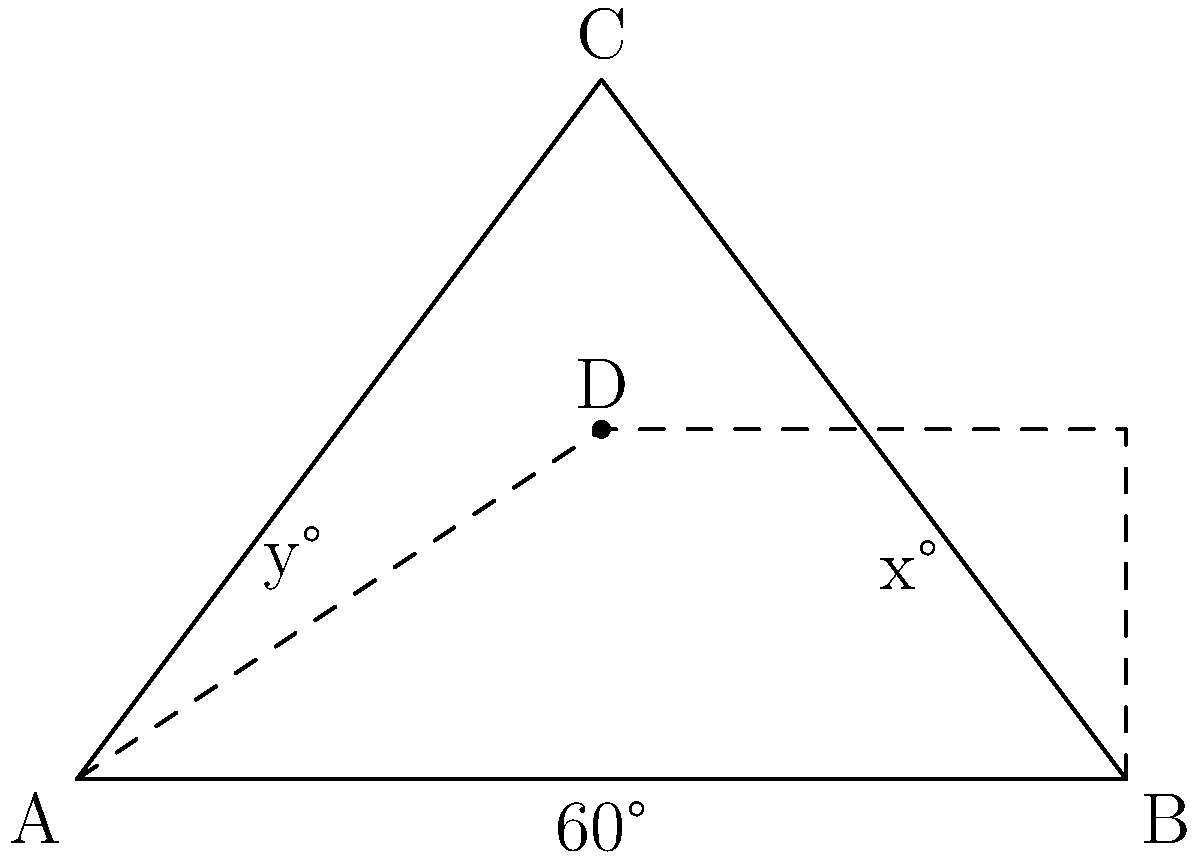For a multi-tiered display stand to showcase Rocket Raccoon props, you're designing a triangular base. The bottom tier forms an equilateral triangle ABC with a 60° angle at the base. Two shelves are placed parallel to the base, dividing the height into three equal parts. If the angle between the bottom shelf and side AC is x°, and the angle between the bottom shelf and side BC is y°, what is the value of x + y? Let's approach this step-by-step:

1) In an equilateral triangle, all angles are 60°. The height of the triangle divides it into two 30-60-90 triangles.

2) In a 30-60-90 triangle, if the shortest side (opposite to 30°) is x, then the hypotenuse (opposite to 90°) is 2x, and the remaining side (opposite to 60°) is x√3.

3) Let's consider the right triangle ACD. We know that ∠CAB = 60° and ∠ACD = 90°. Therefore, ∠ACD = 30°.

4) The shelves divide the height into three equal parts. This means that AD = 2/3 of the height of the triangle.

5) In the 30-60-90 triangle ACD:
   tan(30°) = AD / CD
   1/√3 = (2/3 * h) / (1/2 * AB), where h is the height of the triangle
   h = (√3/2) * AB

6) Now, in the small right triangle formed by the bottom shelf and AC:
   tan(x) = (1/3 * h) / (1/2 * AC)
   tan(x) = (1/3 * √3/2 * AB) / (1/2 * AB)
   tan(x) = 1/√3
   x = 30°

7) Due to the symmetry of the equilateral triangle, y = x = 30°

8) Therefore, x + y = 30° + 30° = 60°
Answer: 60° 